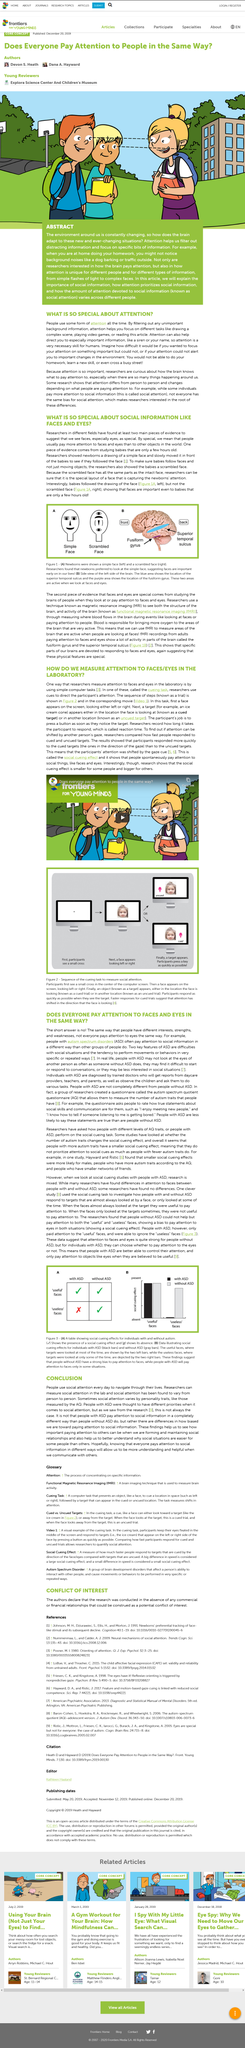Mention a couple of crucial points in this snapshot. The newborns preferred to follow the simple face rather than any other objects or images presented to them. An example of a cued target is the location that a face is looking at. The graph on the right displays data illustrating the effects of social cueing on individuals with and without autism spectrum disorder (ASD). People with ASD do not focus on useless facial expressions. The social cueing effect demonstrates that individuals naturally pay attention to social stimuli, such as faces and eyes, without the need for explicit instruction or cues. 